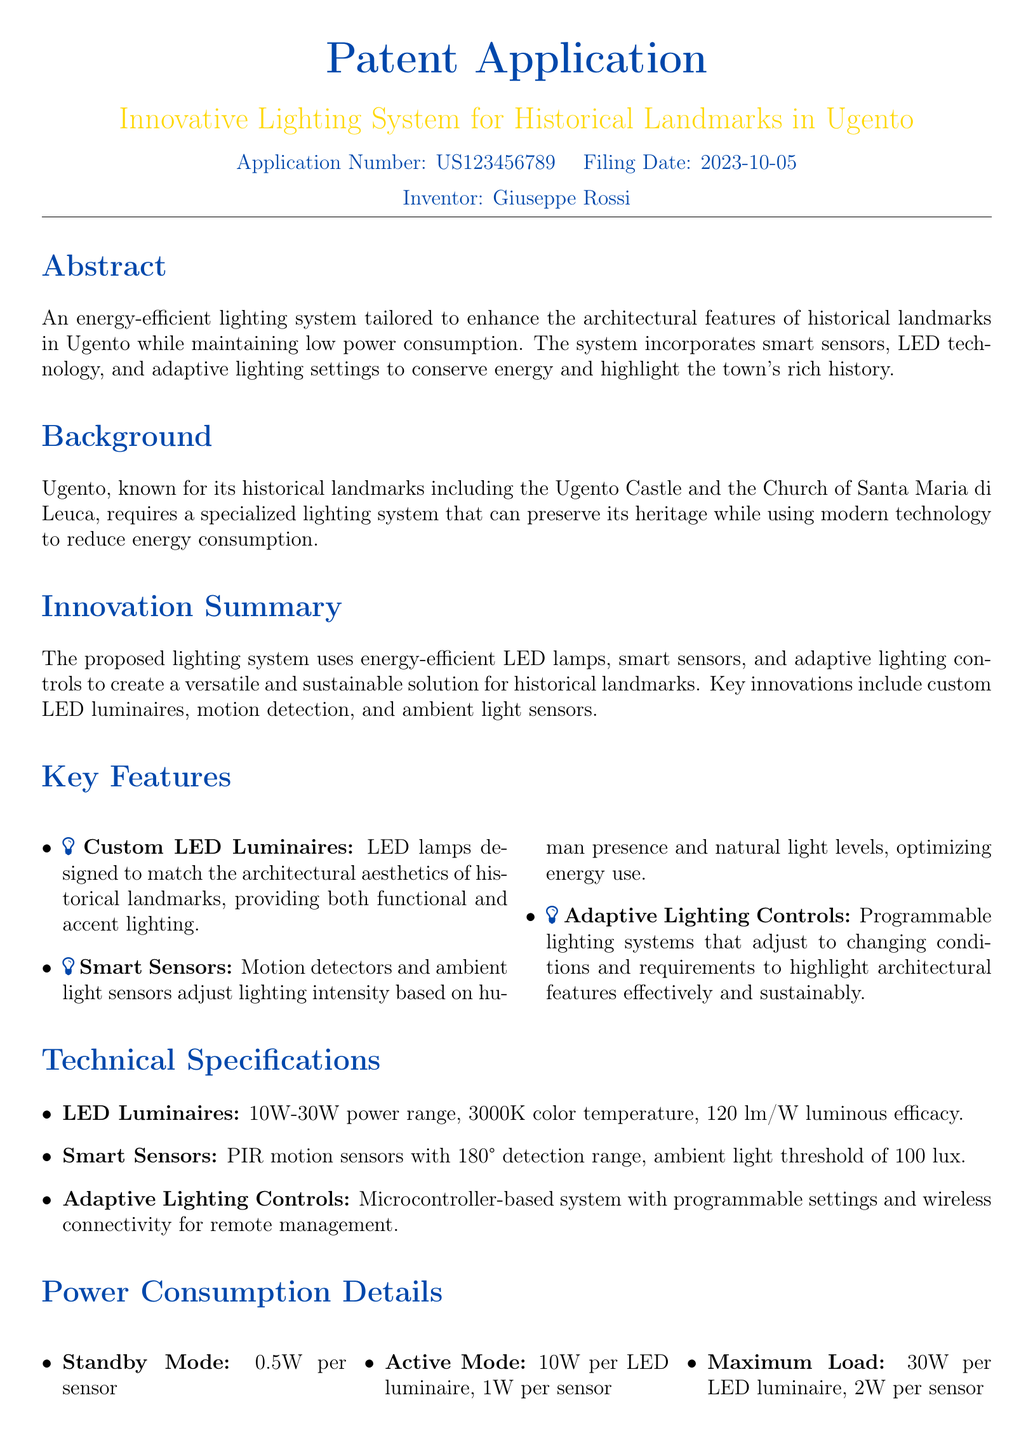What is the application number? The application number is stated in the document for reference, which is US123456789.
Answer: US123456789 Who is the inventor? The document specifically mentions the name of the inventor, which is Giuseppe Rossi.
Answer: Giuseppe Rossi What is the filing date? The filing date is listed in the document, which is 2023-10-05.
Answer: 2023-10-05 What is the color temperature of LED luminaires? The document details the color temperature of the LED luminaires, which is 3000K.
Answer: 3000K What is the luminous efficacy of the LED system? The luminous efficacy of the LED system is given in the document as 120 lm/W.
Answer: 120 lm/W How much power does an LED luminaire consume in active mode? The document provides specifics about power consumption in different modes, stating it is 10W per LED luminaire in active mode.
Answer: 10W What are the key innovations mentioned? The document lists key innovations including custom LED luminaires, smart sensors, and adaptive lighting controls.
Answer: Custom LED Luminaires, Smart Sensors, Adaptive Lighting Controls What is the maximum load of a sensor? The maximum load for a sensor is specified in the document as 2W.
Answer: 2W What is the purpose of the lighting system? The document outlines that the purpose of the lighting system is to enhance architectural features while conserving energy.
Answer: Enhance architectural features while conserving energy 